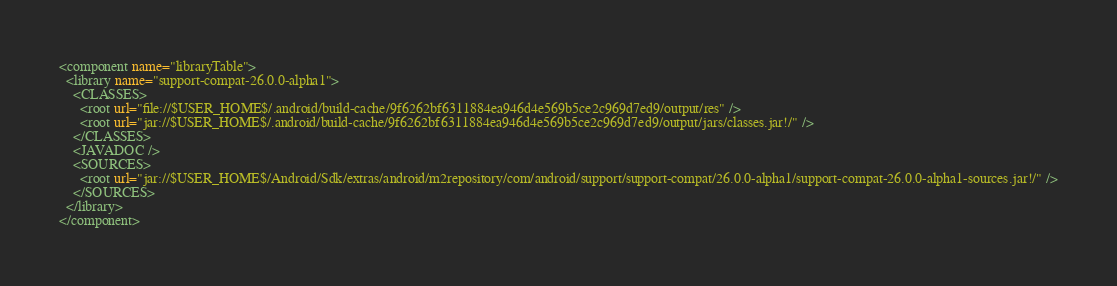<code> <loc_0><loc_0><loc_500><loc_500><_XML_><component name="libraryTable">
  <library name="support-compat-26.0.0-alpha1">
    <CLASSES>
      <root url="file://$USER_HOME$/.android/build-cache/9f6262bf6311884ea946d4e569b5ce2c969d7ed9/output/res" />
      <root url="jar://$USER_HOME$/.android/build-cache/9f6262bf6311884ea946d4e569b5ce2c969d7ed9/output/jars/classes.jar!/" />
    </CLASSES>
    <JAVADOC />
    <SOURCES>
      <root url="jar://$USER_HOME$/Android/Sdk/extras/android/m2repository/com/android/support/support-compat/26.0.0-alpha1/support-compat-26.0.0-alpha1-sources.jar!/" />
    </SOURCES>
  </library>
</component></code> 